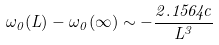Convert formula to latex. <formula><loc_0><loc_0><loc_500><loc_500>\omega _ { 0 } ( L ) - \omega _ { 0 } ( \infty ) \sim - { \frac { 2 . 1 5 6 4 c } { L ^ { 3 } } }</formula> 